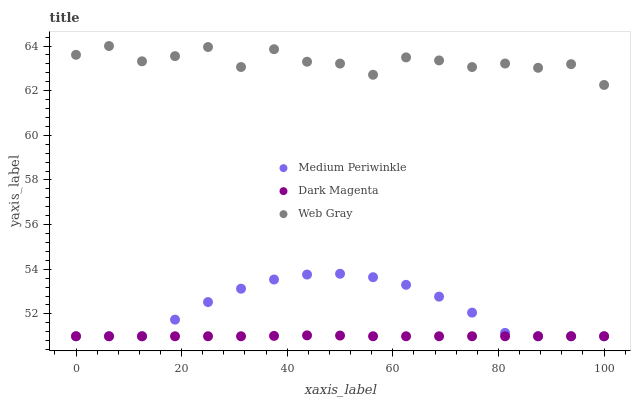Does Dark Magenta have the minimum area under the curve?
Answer yes or no. Yes. Does Web Gray have the maximum area under the curve?
Answer yes or no. Yes. Does Medium Periwinkle have the minimum area under the curve?
Answer yes or no. No. Does Medium Periwinkle have the maximum area under the curve?
Answer yes or no. No. Is Dark Magenta the smoothest?
Answer yes or no. Yes. Is Web Gray the roughest?
Answer yes or no. Yes. Is Medium Periwinkle the smoothest?
Answer yes or no. No. Is Medium Periwinkle the roughest?
Answer yes or no. No. Does Medium Periwinkle have the lowest value?
Answer yes or no. Yes. Does Web Gray have the highest value?
Answer yes or no. Yes. Does Medium Periwinkle have the highest value?
Answer yes or no. No. Is Dark Magenta less than Web Gray?
Answer yes or no. Yes. Is Web Gray greater than Medium Periwinkle?
Answer yes or no. Yes. Does Medium Periwinkle intersect Dark Magenta?
Answer yes or no. Yes. Is Medium Periwinkle less than Dark Magenta?
Answer yes or no. No. Is Medium Periwinkle greater than Dark Magenta?
Answer yes or no. No. Does Dark Magenta intersect Web Gray?
Answer yes or no. No. 